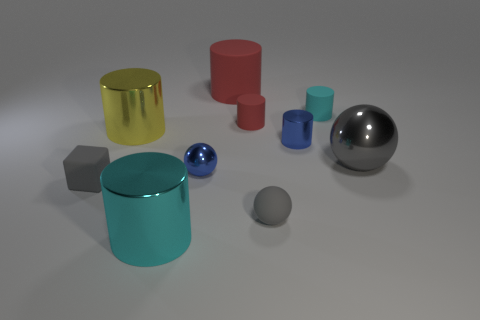How big is the matte cylinder that is to the left of the small cyan thing and in front of the large red matte cylinder?
Your answer should be compact. Small. What number of small gray cylinders have the same material as the large cyan thing?
Make the answer very short. 0. Is the size of the gray matte ball the same as the cyan metal object?
Ensure brevity in your answer.  No. What color is the tiny rubber sphere?
Offer a very short reply. Gray. How many objects are big blue metallic objects or red things?
Ensure brevity in your answer.  2. Are there any blue objects of the same shape as the small cyan object?
Your answer should be very brief. Yes. Is the color of the rubber cylinder to the right of the blue cylinder the same as the large rubber cylinder?
Your answer should be compact. No. The small blue shiny object behind the metal sphere that is left of the small gray sphere is what shape?
Give a very brief answer. Cylinder. Are there any purple rubber blocks that have the same size as the cyan matte thing?
Offer a very short reply. No. Is the number of blue metal cylinders less than the number of tiny green cylinders?
Make the answer very short. No. 